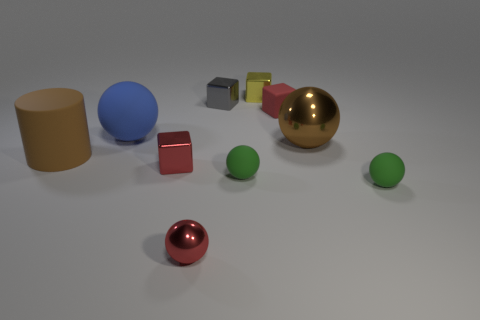There is another big thing that is the same shape as the large metal object; what color is it?
Offer a terse response. Blue. What number of things are either small red objects in front of the brown sphere or green spheres that are on the right side of the yellow thing?
Provide a short and direct response. 3. Is there any other thing that is the same color as the big matte sphere?
Your response must be concise. No. Are there an equal number of red shiny cubes that are on the right side of the yellow shiny block and large spheres on the right side of the red matte block?
Give a very brief answer. No. Are there more big matte cylinders that are in front of the brown metallic object than cyan rubber cubes?
Keep it short and to the point. Yes. How many objects are either large matte objects behind the cylinder or cubes?
Your answer should be compact. 5. How many other purple cylinders have the same material as the cylinder?
Keep it short and to the point. 0. There is a tiny rubber object that is the same color as the small shiny ball; what is its shape?
Provide a succinct answer. Cube. Is there a large brown metallic thing of the same shape as the big blue thing?
Provide a short and direct response. Yes. There is a brown thing that is the same size as the brown cylinder; what is its shape?
Provide a short and direct response. Sphere. 